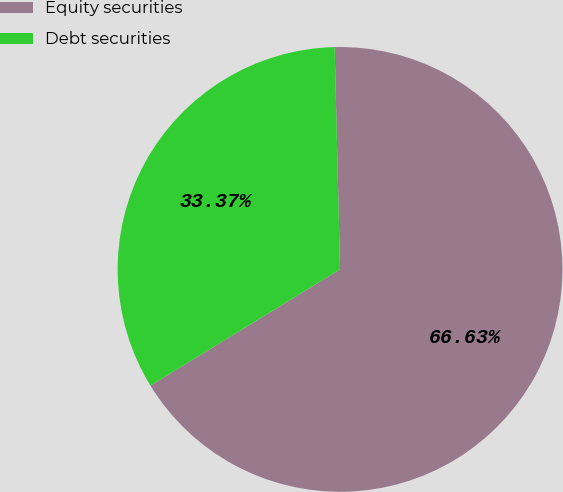<chart> <loc_0><loc_0><loc_500><loc_500><pie_chart><fcel>Equity securities<fcel>Debt securities<nl><fcel>66.63%<fcel>33.37%<nl></chart> 